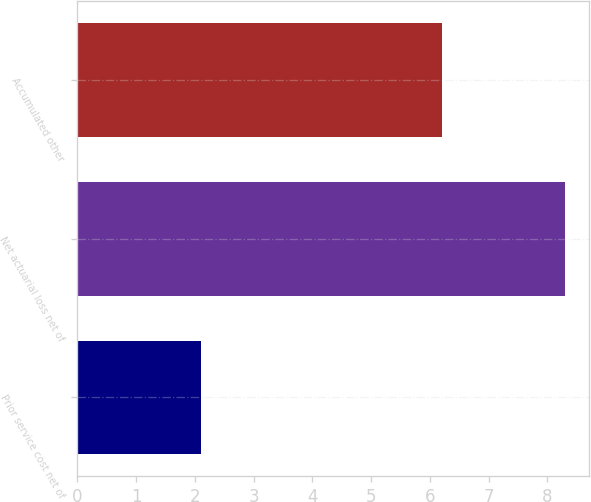Convert chart to OTSL. <chart><loc_0><loc_0><loc_500><loc_500><bar_chart><fcel>Prior service cost net of<fcel>Net actuarial loss net of<fcel>Accumulated other<nl><fcel>2.1<fcel>8.3<fcel>6.2<nl></chart> 